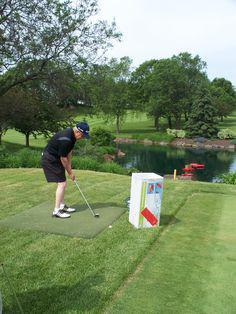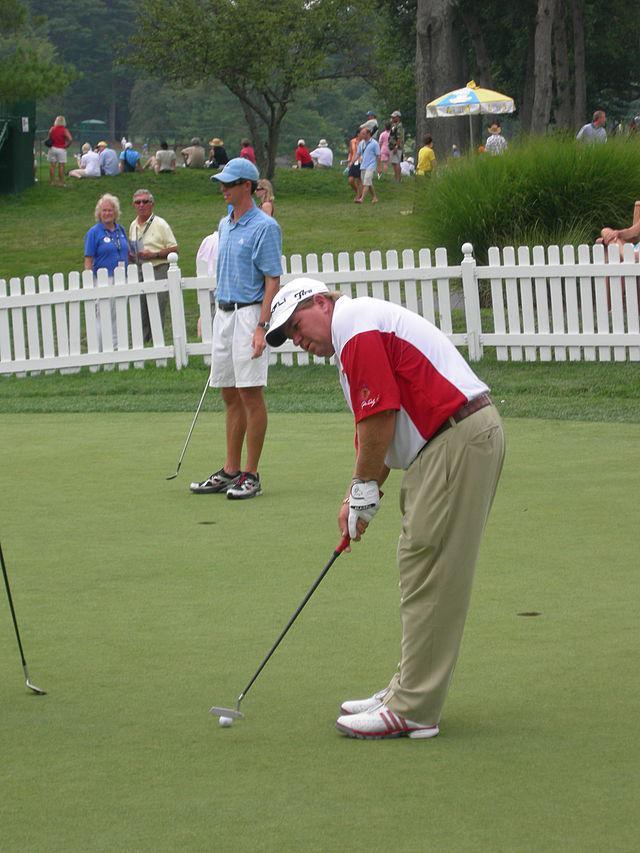The first image is the image on the left, the second image is the image on the right. For the images shown, is this caption "A red and white checked flag sits on the golf course in one of the images." true? Answer yes or no. No. The first image is the image on the left, the second image is the image on the right. Examine the images to the left and right. Is the description "An image shows a group of people on a golf green with a red checkered flag on a pole." accurate? Answer yes or no. No. 